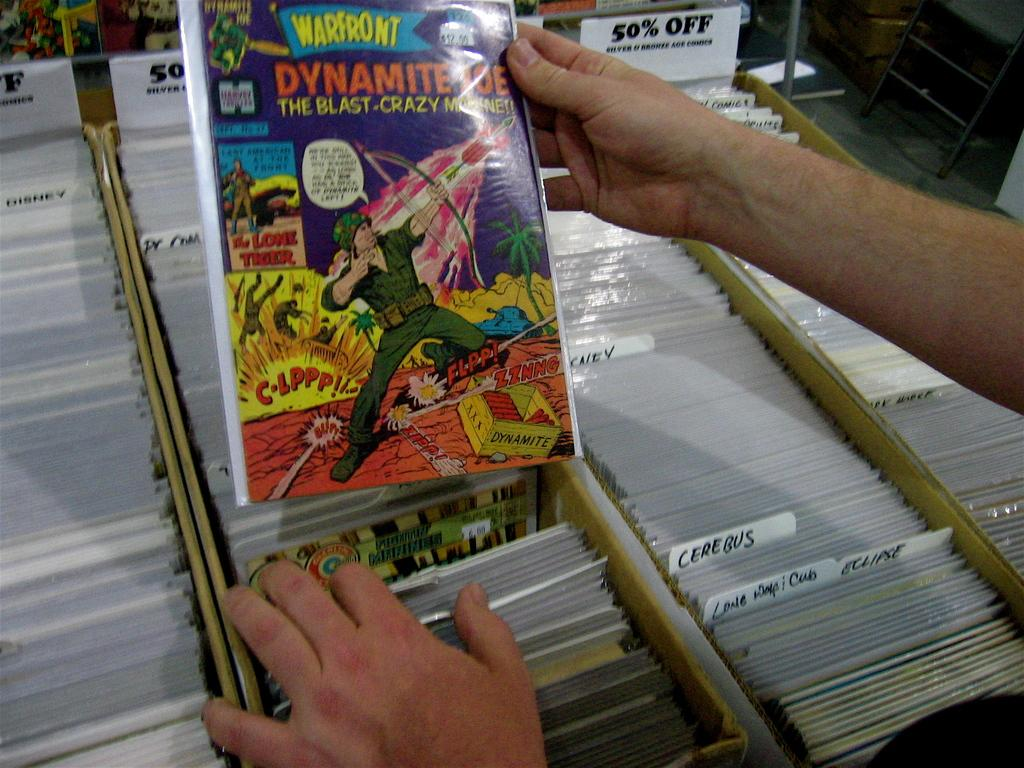<image>
Create a compact narrative representing the image presented. a person holding an x men comic with dynamite on it 